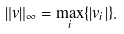Convert formula to latex. <formula><loc_0><loc_0><loc_500><loc_500>\| v \| _ { \infty } = \max _ { i } \{ | v _ { i } | \} .</formula> 